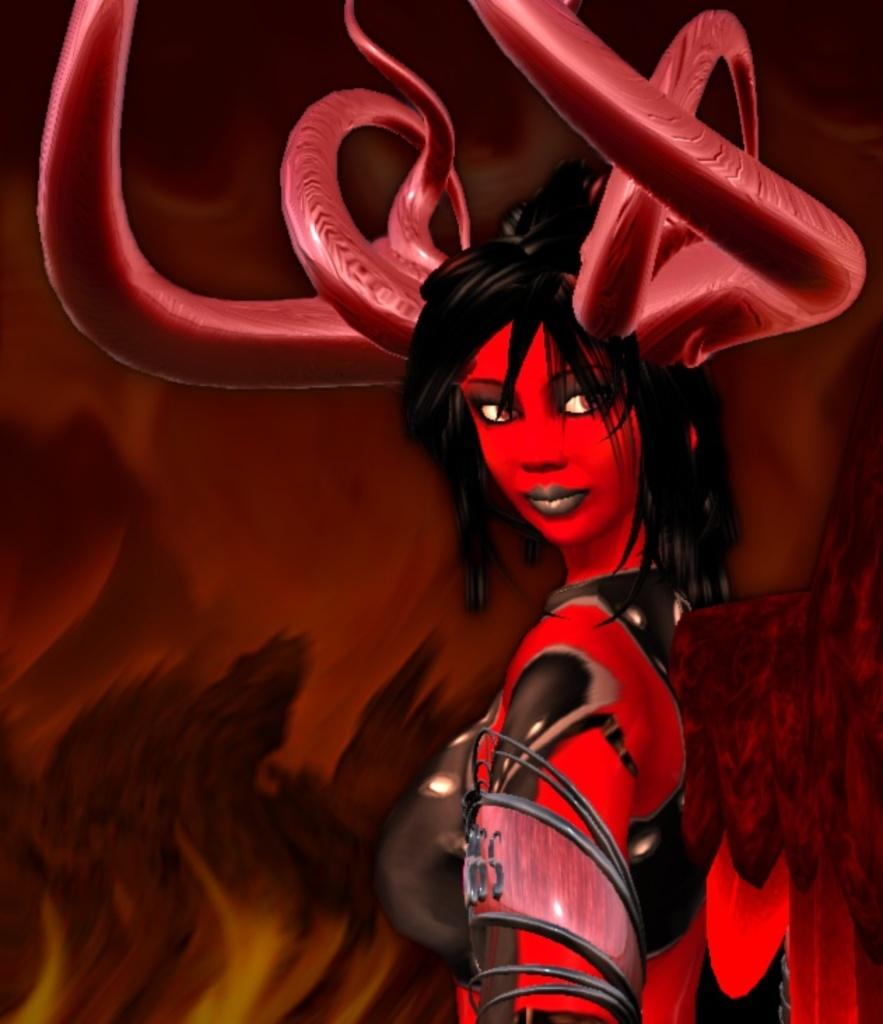What type of image is being described? The image is animated. Can you describe the person in the image? The person in the image is wearing red clothing and has horns on their head. What color is the background of the image? The background of the image is brown. What type of notebook is the person holding in the image? There is no notebook present in the image. What committee is the person a part of in the image? There is no committee or any indication of a group or organization in the image. 